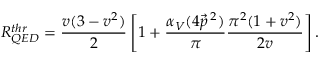Convert formula to latex. <formula><loc_0><loc_0><loc_500><loc_500>R _ { Q E D } ^ { t h r } = \frac { v ( 3 - v ^ { 2 } ) } { 2 } \left [ 1 + \frac { \alpha _ { V } ( 4 \vec { p } \, ^ { 2 } ) } { \pi } \frac { \pi ^ { 2 } ( 1 + v ^ { 2 } ) } { 2 v } \right ] .</formula> 